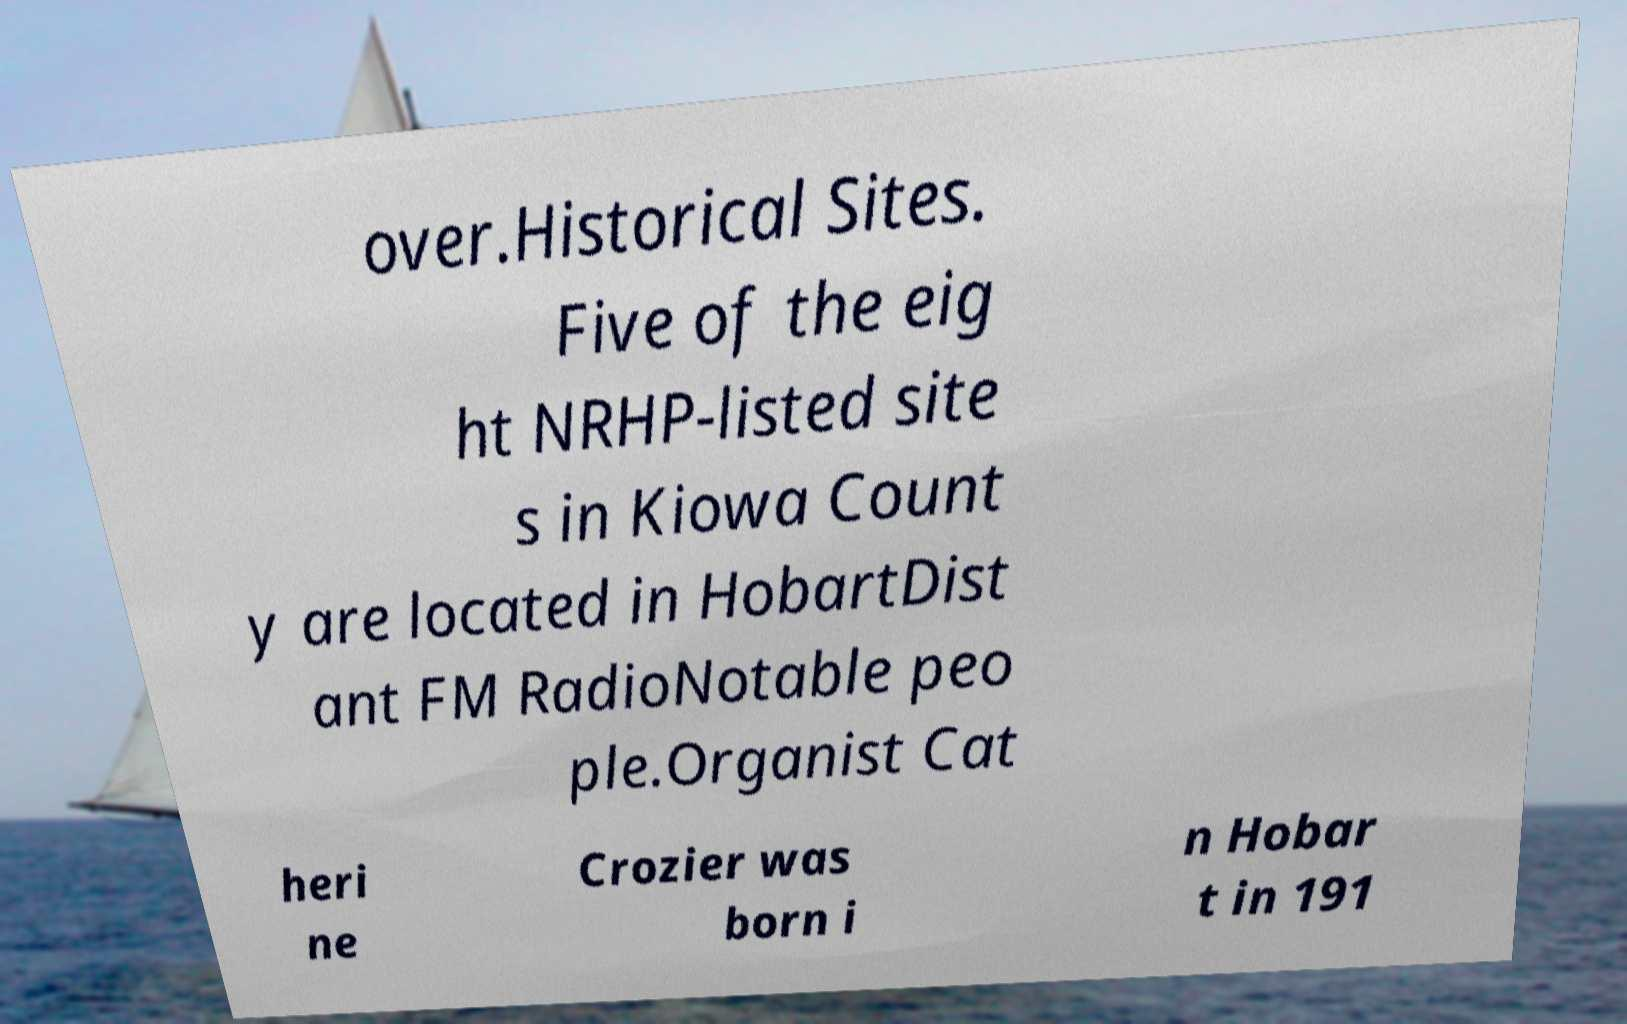There's text embedded in this image that I need extracted. Can you transcribe it verbatim? over.Historical Sites. Five of the eig ht NRHP-listed site s in Kiowa Count y are located in HobartDist ant FM RadioNotable peo ple.Organist Cat heri ne Crozier was born i n Hobar t in 191 